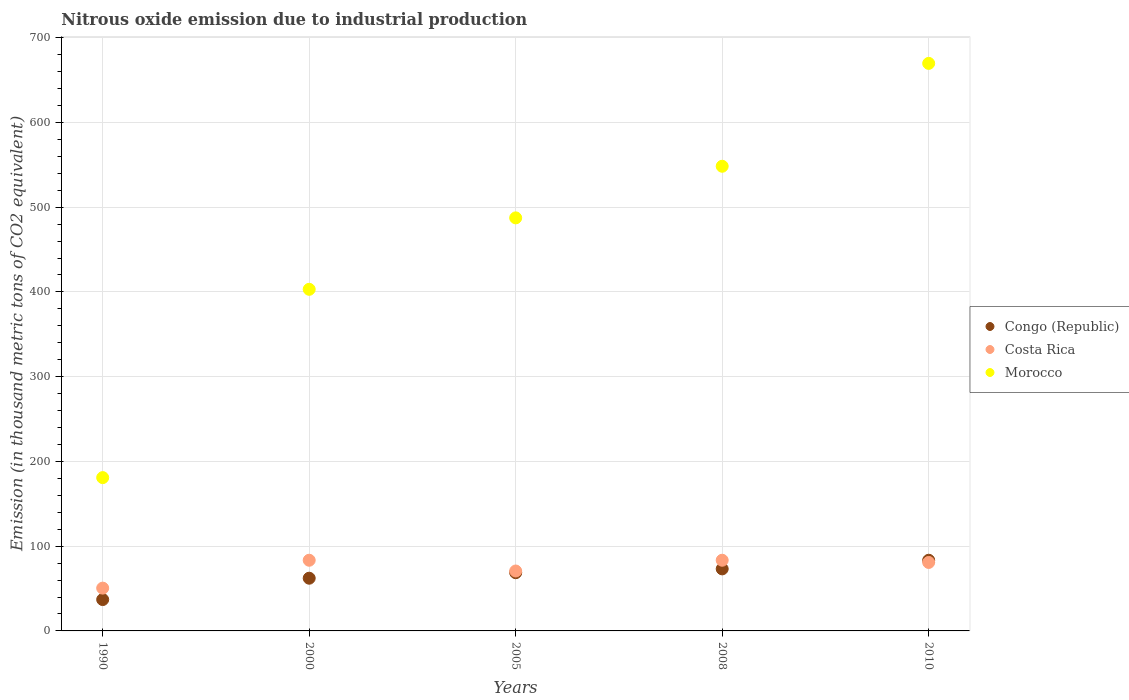What is the amount of nitrous oxide emitted in Congo (Republic) in 2005?
Ensure brevity in your answer.  68.7. Across all years, what is the maximum amount of nitrous oxide emitted in Costa Rica?
Ensure brevity in your answer.  83.4. Across all years, what is the minimum amount of nitrous oxide emitted in Morocco?
Your answer should be compact. 180.9. In which year was the amount of nitrous oxide emitted in Morocco minimum?
Your answer should be very brief. 1990. What is the total amount of nitrous oxide emitted in Congo (Republic) in the graph?
Provide a succinct answer. 324.5. What is the difference between the amount of nitrous oxide emitted in Costa Rica in 2000 and that in 2005?
Offer a terse response. 12.7. What is the difference between the amount of nitrous oxide emitted in Costa Rica in 2005 and the amount of nitrous oxide emitted in Congo (Republic) in 2010?
Your answer should be compact. -12.7. What is the average amount of nitrous oxide emitted in Morocco per year?
Offer a terse response. 457.88. In the year 2005, what is the difference between the amount of nitrous oxide emitted in Morocco and amount of nitrous oxide emitted in Costa Rica?
Your answer should be compact. 416.7. What is the ratio of the amount of nitrous oxide emitted in Congo (Republic) in 1990 to that in 2010?
Provide a succinct answer. 0.44. Is the amount of nitrous oxide emitted in Congo (Republic) in 1990 less than that in 2000?
Make the answer very short. Yes. What is the difference between the highest and the second highest amount of nitrous oxide emitted in Morocco?
Provide a short and direct response. 121.4. What is the difference between the highest and the lowest amount of nitrous oxide emitted in Costa Rica?
Provide a succinct answer. 32.9. In how many years, is the amount of nitrous oxide emitted in Costa Rica greater than the average amount of nitrous oxide emitted in Costa Rica taken over all years?
Keep it short and to the point. 3. Is the sum of the amount of nitrous oxide emitted in Congo (Republic) in 1990 and 2000 greater than the maximum amount of nitrous oxide emitted in Costa Rica across all years?
Offer a very short reply. Yes. How many dotlines are there?
Offer a terse response. 3. What is the difference between two consecutive major ticks on the Y-axis?
Keep it short and to the point. 100. Are the values on the major ticks of Y-axis written in scientific E-notation?
Keep it short and to the point. No. How many legend labels are there?
Ensure brevity in your answer.  3. How are the legend labels stacked?
Ensure brevity in your answer.  Vertical. What is the title of the graph?
Give a very brief answer. Nitrous oxide emission due to industrial production. Does "Belgium" appear as one of the legend labels in the graph?
Offer a terse response. No. What is the label or title of the Y-axis?
Give a very brief answer. Emission (in thousand metric tons of CO2 equivalent). What is the Emission (in thousand metric tons of CO2 equivalent) of Congo (Republic) in 1990?
Make the answer very short. 37. What is the Emission (in thousand metric tons of CO2 equivalent) of Costa Rica in 1990?
Your answer should be compact. 50.5. What is the Emission (in thousand metric tons of CO2 equivalent) of Morocco in 1990?
Provide a short and direct response. 180.9. What is the Emission (in thousand metric tons of CO2 equivalent) in Congo (Republic) in 2000?
Provide a succinct answer. 62.2. What is the Emission (in thousand metric tons of CO2 equivalent) of Costa Rica in 2000?
Give a very brief answer. 83.4. What is the Emission (in thousand metric tons of CO2 equivalent) in Morocco in 2000?
Provide a succinct answer. 403.1. What is the Emission (in thousand metric tons of CO2 equivalent) of Congo (Republic) in 2005?
Make the answer very short. 68.7. What is the Emission (in thousand metric tons of CO2 equivalent) of Costa Rica in 2005?
Your response must be concise. 70.7. What is the Emission (in thousand metric tons of CO2 equivalent) in Morocco in 2005?
Offer a very short reply. 487.4. What is the Emission (in thousand metric tons of CO2 equivalent) in Congo (Republic) in 2008?
Your answer should be very brief. 73.2. What is the Emission (in thousand metric tons of CO2 equivalent) in Costa Rica in 2008?
Provide a succinct answer. 83.4. What is the Emission (in thousand metric tons of CO2 equivalent) in Morocco in 2008?
Your answer should be compact. 548.3. What is the Emission (in thousand metric tons of CO2 equivalent) of Congo (Republic) in 2010?
Keep it short and to the point. 83.4. What is the Emission (in thousand metric tons of CO2 equivalent) in Costa Rica in 2010?
Offer a very short reply. 80.8. What is the Emission (in thousand metric tons of CO2 equivalent) of Morocco in 2010?
Offer a terse response. 669.7. Across all years, what is the maximum Emission (in thousand metric tons of CO2 equivalent) in Congo (Republic)?
Offer a very short reply. 83.4. Across all years, what is the maximum Emission (in thousand metric tons of CO2 equivalent) of Costa Rica?
Offer a very short reply. 83.4. Across all years, what is the maximum Emission (in thousand metric tons of CO2 equivalent) in Morocco?
Make the answer very short. 669.7. Across all years, what is the minimum Emission (in thousand metric tons of CO2 equivalent) of Congo (Republic)?
Your response must be concise. 37. Across all years, what is the minimum Emission (in thousand metric tons of CO2 equivalent) in Costa Rica?
Ensure brevity in your answer.  50.5. Across all years, what is the minimum Emission (in thousand metric tons of CO2 equivalent) in Morocco?
Your response must be concise. 180.9. What is the total Emission (in thousand metric tons of CO2 equivalent) in Congo (Republic) in the graph?
Your response must be concise. 324.5. What is the total Emission (in thousand metric tons of CO2 equivalent) in Costa Rica in the graph?
Give a very brief answer. 368.8. What is the total Emission (in thousand metric tons of CO2 equivalent) in Morocco in the graph?
Give a very brief answer. 2289.4. What is the difference between the Emission (in thousand metric tons of CO2 equivalent) of Congo (Republic) in 1990 and that in 2000?
Your answer should be very brief. -25.2. What is the difference between the Emission (in thousand metric tons of CO2 equivalent) in Costa Rica in 1990 and that in 2000?
Make the answer very short. -32.9. What is the difference between the Emission (in thousand metric tons of CO2 equivalent) in Morocco in 1990 and that in 2000?
Your answer should be compact. -222.2. What is the difference between the Emission (in thousand metric tons of CO2 equivalent) of Congo (Republic) in 1990 and that in 2005?
Offer a very short reply. -31.7. What is the difference between the Emission (in thousand metric tons of CO2 equivalent) of Costa Rica in 1990 and that in 2005?
Keep it short and to the point. -20.2. What is the difference between the Emission (in thousand metric tons of CO2 equivalent) in Morocco in 1990 and that in 2005?
Provide a succinct answer. -306.5. What is the difference between the Emission (in thousand metric tons of CO2 equivalent) of Congo (Republic) in 1990 and that in 2008?
Provide a short and direct response. -36.2. What is the difference between the Emission (in thousand metric tons of CO2 equivalent) of Costa Rica in 1990 and that in 2008?
Your answer should be compact. -32.9. What is the difference between the Emission (in thousand metric tons of CO2 equivalent) of Morocco in 1990 and that in 2008?
Provide a short and direct response. -367.4. What is the difference between the Emission (in thousand metric tons of CO2 equivalent) in Congo (Republic) in 1990 and that in 2010?
Keep it short and to the point. -46.4. What is the difference between the Emission (in thousand metric tons of CO2 equivalent) in Costa Rica in 1990 and that in 2010?
Offer a terse response. -30.3. What is the difference between the Emission (in thousand metric tons of CO2 equivalent) of Morocco in 1990 and that in 2010?
Your answer should be compact. -488.8. What is the difference between the Emission (in thousand metric tons of CO2 equivalent) of Costa Rica in 2000 and that in 2005?
Provide a succinct answer. 12.7. What is the difference between the Emission (in thousand metric tons of CO2 equivalent) of Morocco in 2000 and that in 2005?
Give a very brief answer. -84.3. What is the difference between the Emission (in thousand metric tons of CO2 equivalent) in Congo (Republic) in 2000 and that in 2008?
Offer a very short reply. -11. What is the difference between the Emission (in thousand metric tons of CO2 equivalent) in Morocco in 2000 and that in 2008?
Give a very brief answer. -145.2. What is the difference between the Emission (in thousand metric tons of CO2 equivalent) of Congo (Republic) in 2000 and that in 2010?
Ensure brevity in your answer.  -21.2. What is the difference between the Emission (in thousand metric tons of CO2 equivalent) of Costa Rica in 2000 and that in 2010?
Ensure brevity in your answer.  2.6. What is the difference between the Emission (in thousand metric tons of CO2 equivalent) of Morocco in 2000 and that in 2010?
Offer a very short reply. -266.6. What is the difference between the Emission (in thousand metric tons of CO2 equivalent) of Congo (Republic) in 2005 and that in 2008?
Provide a succinct answer. -4.5. What is the difference between the Emission (in thousand metric tons of CO2 equivalent) in Costa Rica in 2005 and that in 2008?
Make the answer very short. -12.7. What is the difference between the Emission (in thousand metric tons of CO2 equivalent) in Morocco in 2005 and that in 2008?
Offer a very short reply. -60.9. What is the difference between the Emission (in thousand metric tons of CO2 equivalent) in Congo (Republic) in 2005 and that in 2010?
Provide a succinct answer. -14.7. What is the difference between the Emission (in thousand metric tons of CO2 equivalent) in Costa Rica in 2005 and that in 2010?
Keep it short and to the point. -10.1. What is the difference between the Emission (in thousand metric tons of CO2 equivalent) in Morocco in 2005 and that in 2010?
Your answer should be compact. -182.3. What is the difference between the Emission (in thousand metric tons of CO2 equivalent) of Congo (Republic) in 2008 and that in 2010?
Provide a short and direct response. -10.2. What is the difference between the Emission (in thousand metric tons of CO2 equivalent) in Costa Rica in 2008 and that in 2010?
Your answer should be compact. 2.6. What is the difference between the Emission (in thousand metric tons of CO2 equivalent) in Morocco in 2008 and that in 2010?
Give a very brief answer. -121.4. What is the difference between the Emission (in thousand metric tons of CO2 equivalent) of Congo (Republic) in 1990 and the Emission (in thousand metric tons of CO2 equivalent) of Costa Rica in 2000?
Provide a succinct answer. -46.4. What is the difference between the Emission (in thousand metric tons of CO2 equivalent) in Congo (Republic) in 1990 and the Emission (in thousand metric tons of CO2 equivalent) in Morocco in 2000?
Give a very brief answer. -366.1. What is the difference between the Emission (in thousand metric tons of CO2 equivalent) in Costa Rica in 1990 and the Emission (in thousand metric tons of CO2 equivalent) in Morocco in 2000?
Make the answer very short. -352.6. What is the difference between the Emission (in thousand metric tons of CO2 equivalent) in Congo (Republic) in 1990 and the Emission (in thousand metric tons of CO2 equivalent) in Costa Rica in 2005?
Your answer should be very brief. -33.7. What is the difference between the Emission (in thousand metric tons of CO2 equivalent) in Congo (Republic) in 1990 and the Emission (in thousand metric tons of CO2 equivalent) in Morocco in 2005?
Give a very brief answer. -450.4. What is the difference between the Emission (in thousand metric tons of CO2 equivalent) in Costa Rica in 1990 and the Emission (in thousand metric tons of CO2 equivalent) in Morocco in 2005?
Your answer should be compact. -436.9. What is the difference between the Emission (in thousand metric tons of CO2 equivalent) of Congo (Republic) in 1990 and the Emission (in thousand metric tons of CO2 equivalent) of Costa Rica in 2008?
Your response must be concise. -46.4. What is the difference between the Emission (in thousand metric tons of CO2 equivalent) in Congo (Republic) in 1990 and the Emission (in thousand metric tons of CO2 equivalent) in Morocco in 2008?
Offer a terse response. -511.3. What is the difference between the Emission (in thousand metric tons of CO2 equivalent) of Costa Rica in 1990 and the Emission (in thousand metric tons of CO2 equivalent) of Morocco in 2008?
Offer a very short reply. -497.8. What is the difference between the Emission (in thousand metric tons of CO2 equivalent) of Congo (Republic) in 1990 and the Emission (in thousand metric tons of CO2 equivalent) of Costa Rica in 2010?
Keep it short and to the point. -43.8. What is the difference between the Emission (in thousand metric tons of CO2 equivalent) of Congo (Republic) in 1990 and the Emission (in thousand metric tons of CO2 equivalent) of Morocco in 2010?
Offer a very short reply. -632.7. What is the difference between the Emission (in thousand metric tons of CO2 equivalent) of Costa Rica in 1990 and the Emission (in thousand metric tons of CO2 equivalent) of Morocco in 2010?
Give a very brief answer. -619.2. What is the difference between the Emission (in thousand metric tons of CO2 equivalent) of Congo (Republic) in 2000 and the Emission (in thousand metric tons of CO2 equivalent) of Morocco in 2005?
Your answer should be very brief. -425.2. What is the difference between the Emission (in thousand metric tons of CO2 equivalent) in Costa Rica in 2000 and the Emission (in thousand metric tons of CO2 equivalent) in Morocco in 2005?
Keep it short and to the point. -404. What is the difference between the Emission (in thousand metric tons of CO2 equivalent) of Congo (Republic) in 2000 and the Emission (in thousand metric tons of CO2 equivalent) of Costa Rica in 2008?
Give a very brief answer. -21.2. What is the difference between the Emission (in thousand metric tons of CO2 equivalent) of Congo (Republic) in 2000 and the Emission (in thousand metric tons of CO2 equivalent) of Morocco in 2008?
Your answer should be very brief. -486.1. What is the difference between the Emission (in thousand metric tons of CO2 equivalent) of Costa Rica in 2000 and the Emission (in thousand metric tons of CO2 equivalent) of Morocco in 2008?
Keep it short and to the point. -464.9. What is the difference between the Emission (in thousand metric tons of CO2 equivalent) of Congo (Republic) in 2000 and the Emission (in thousand metric tons of CO2 equivalent) of Costa Rica in 2010?
Ensure brevity in your answer.  -18.6. What is the difference between the Emission (in thousand metric tons of CO2 equivalent) in Congo (Republic) in 2000 and the Emission (in thousand metric tons of CO2 equivalent) in Morocco in 2010?
Provide a short and direct response. -607.5. What is the difference between the Emission (in thousand metric tons of CO2 equivalent) in Costa Rica in 2000 and the Emission (in thousand metric tons of CO2 equivalent) in Morocco in 2010?
Offer a very short reply. -586.3. What is the difference between the Emission (in thousand metric tons of CO2 equivalent) in Congo (Republic) in 2005 and the Emission (in thousand metric tons of CO2 equivalent) in Costa Rica in 2008?
Offer a very short reply. -14.7. What is the difference between the Emission (in thousand metric tons of CO2 equivalent) in Congo (Republic) in 2005 and the Emission (in thousand metric tons of CO2 equivalent) in Morocco in 2008?
Your answer should be compact. -479.6. What is the difference between the Emission (in thousand metric tons of CO2 equivalent) of Costa Rica in 2005 and the Emission (in thousand metric tons of CO2 equivalent) of Morocco in 2008?
Offer a very short reply. -477.6. What is the difference between the Emission (in thousand metric tons of CO2 equivalent) in Congo (Republic) in 2005 and the Emission (in thousand metric tons of CO2 equivalent) in Costa Rica in 2010?
Your answer should be compact. -12.1. What is the difference between the Emission (in thousand metric tons of CO2 equivalent) in Congo (Republic) in 2005 and the Emission (in thousand metric tons of CO2 equivalent) in Morocco in 2010?
Provide a succinct answer. -601. What is the difference between the Emission (in thousand metric tons of CO2 equivalent) of Costa Rica in 2005 and the Emission (in thousand metric tons of CO2 equivalent) of Morocco in 2010?
Give a very brief answer. -599. What is the difference between the Emission (in thousand metric tons of CO2 equivalent) in Congo (Republic) in 2008 and the Emission (in thousand metric tons of CO2 equivalent) in Morocco in 2010?
Offer a terse response. -596.5. What is the difference between the Emission (in thousand metric tons of CO2 equivalent) of Costa Rica in 2008 and the Emission (in thousand metric tons of CO2 equivalent) of Morocco in 2010?
Ensure brevity in your answer.  -586.3. What is the average Emission (in thousand metric tons of CO2 equivalent) in Congo (Republic) per year?
Provide a short and direct response. 64.9. What is the average Emission (in thousand metric tons of CO2 equivalent) of Costa Rica per year?
Provide a succinct answer. 73.76. What is the average Emission (in thousand metric tons of CO2 equivalent) of Morocco per year?
Your answer should be compact. 457.88. In the year 1990, what is the difference between the Emission (in thousand metric tons of CO2 equivalent) in Congo (Republic) and Emission (in thousand metric tons of CO2 equivalent) in Costa Rica?
Ensure brevity in your answer.  -13.5. In the year 1990, what is the difference between the Emission (in thousand metric tons of CO2 equivalent) of Congo (Republic) and Emission (in thousand metric tons of CO2 equivalent) of Morocco?
Keep it short and to the point. -143.9. In the year 1990, what is the difference between the Emission (in thousand metric tons of CO2 equivalent) of Costa Rica and Emission (in thousand metric tons of CO2 equivalent) of Morocco?
Give a very brief answer. -130.4. In the year 2000, what is the difference between the Emission (in thousand metric tons of CO2 equivalent) of Congo (Republic) and Emission (in thousand metric tons of CO2 equivalent) of Costa Rica?
Your answer should be compact. -21.2. In the year 2000, what is the difference between the Emission (in thousand metric tons of CO2 equivalent) of Congo (Republic) and Emission (in thousand metric tons of CO2 equivalent) of Morocco?
Keep it short and to the point. -340.9. In the year 2000, what is the difference between the Emission (in thousand metric tons of CO2 equivalent) in Costa Rica and Emission (in thousand metric tons of CO2 equivalent) in Morocco?
Provide a succinct answer. -319.7. In the year 2005, what is the difference between the Emission (in thousand metric tons of CO2 equivalent) of Congo (Republic) and Emission (in thousand metric tons of CO2 equivalent) of Morocco?
Offer a very short reply. -418.7. In the year 2005, what is the difference between the Emission (in thousand metric tons of CO2 equivalent) in Costa Rica and Emission (in thousand metric tons of CO2 equivalent) in Morocco?
Keep it short and to the point. -416.7. In the year 2008, what is the difference between the Emission (in thousand metric tons of CO2 equivalent) in Congo (Republic) and Emission (in thousand metric tons of CO2 equivalent) in Costa Rica?
Provide a succinct answer. -10.2. In the year 2008, what is the difference between the Emission (in thousand metric tons of CO2 equivalent) of Congo (Republic) and Emission (in thousand metric tons of CO2 equivalent) of Morocco?
Your answer should be very brief. -475.1. In the year 2008, what is the difference between the Emission (in thousand metric tons of CO2 equivalent) of Costa Rica and Emission (in thousand metric tons of CO2 equivalent) of Morocco?
Provide a succinct answer. -464.9. In the year 2010, what is the difference between the Emission (in thousand metric tons of CO2 equivalent) of Congo (Republic) and Emission (in thousand metric tons of CO2 equivalent) of Costa Rica?
Ensure brevity in your answer.  2.6. In the year 2010, what is the difference between the Emission (in thousand metric tons of CO2 equivalent) of Congo (Republic) and Emission (in thousand metric tons of CO2 equivalent) of Morocco?
Your answer should be compact. -586.3. In the year 2010, what is the difference between the Emission (in thousand metric tons of CO2 equivalent) of Costa Rica and Emission (in thousand metric tons of CO2 equivalent) of Morocco?
Your response must be concise. -588.9. What is the ratio of the Emission (in thousand metric tons of CO2 equivalent) of Congo (Republic) in 1990 to that in 2000?
Provide a succinct answer. 0.59. What is the ratio of the Emission (in thousand metric tons of CO2 equivalent) in Costa Rica in 1990 to that in 2000?
Your answer should be compact. 0.61. What is the ratio of the Emission (in thousand metric tons of CO2 equivalent) in Morocco in 1990 to that in 2000?
Your answer should be very brief. 0.45. What is the ratio of the Emission (in thousand metric tons of CO2 equivalent) in Congo (Republic) in 1990 to that in 2005?
Offer a terse response. 0.54. What is the ratio of the Emission (in thousand metric tons of CO2 equivalent) of Costa Rica in 1990 to that in 2005?
Give a very brief answer. 0.71. What is the ratio of the Emission (in thousand metric tons of CO2 equivalent) in Morocco in 1990 to that in 2005?
Keep it short and to the point. 0.37. What is the ratio of the Emission (in thousand metric tons of CO2 equivalent) in Congo (Republic) in 1990 to that in 2008?
Offer a very short reply. 0.51. What is the ratio of the Emission (in thousand metric tons of CO2 equivalent) of Costa Rica in 1990 to that in 2008?
Give a very brief answer. 0.61. What is the ratio of the Emission (in thousand metric tons of CO2 equivalent) in Morocco in 1990 to that in 2008?
Ensure brevity in your answer.  0.33. What is the ratio of the Emission (in thousand metric tons of CO2 equivalent) in Congo (Republic) in 1990 to that in 2010?
Your answer should be compact. 0.44. What is the ratio of the Emission (in thousand metric tons of CO2 equivalent) of Morocco in 1990 to that in 2010?
Your answer should be very brief. 0.27. What is the ratio of the Emission (in thousand metric tons of CO2 equivalent) of Congo (Republic) in 2000 to that in 2005?
Your answer should be compact. 0.91. What is the ratio of the Emission (in thousand metric tons of CO2 equivalent) in Costa Rica in 2000 to that in 2005?
Provide a short and direct response. 1.18. What is the ratio of the Emission (in thousand metric tons of CO2 equivalent) of Morocco in 2000 to that in 2005?
Give a very brief answer. 0.83. What is the ratio of the Emission (in thousand metric tons of CO2 equivalent) in Congo (Republic) in 2000 to that in 2008?
Offer a very short reply. 0.85. What is the ratio of the Emission (in thousand metric tons of CO2 equivalent) in Morocco in 2000 to that in 2008?
Provide a succinct answer. 0.74. What is the ratio of the Emission (in thousand metric tons of CO2 equivalent) of Congo (Republic) in 2000 to that in 2010?
Provide a succinct answer. 0.75. What is the ratio of the Emission (in thousand metric tons of CO2 equivalent) of Costa Rica in 2000 to that in 2010?
Provide a short and direct response. 1.03. What is the ratio of the Emission (in thousand metric tons of CO2 equivalent) in Morocco in 2000 to that in 2010?
Give a very brief answer. 0.6. What is the ratio of the Emission (in thousand metric tons of CO2 equivalent) in Congo (Republic) in 2005 to that in 2008?
Offer a very short reply. 0.94. What is the ratio of the Emission (in thousand metric tons of CO2 equivalent) of Costa Rica in 2005 to that in 2008?
Provide a short and direct response. 0.85. What is the ratio of the Emission (in thousand metric tons of CO2 equivalent) in Morocco in 2005 to that in 2008?
Provide a succinct answer. 0.89. What is the ratio of the Emission (in thousand metric tons of CO2 equivalent) of Congo (Republic) in 2005 to that in 2010?
Make the answer very short. 0.82. What is the ratio of the Emission (in thousand metric tons of CO2 equivalent) of Costa Rica in 2005 to that in 2010?
Offer a terse response. 0.88. What is the ratio of the Emission (in thousand metric tons of CO2 equivalent) of Morocco in 2005 to that in 2010?
Provide a short and direct response. 0.73. What is the ratio of the Emission (in thousand metric tons of CO2 equivalent) of Congo (Republic) in 2008 to that in 2010?
Your response must be concise. 0.88. What is the ratio of the Emission (in thousand metric tons of CO2 equivalent) of Costa Rica in 2008 to that in 2010?
Provide a succinct answer. 1.03. What is the ratio of the Emission (in thousand metric tons of CO2 equivalent) of Morocco in 2008 to that in 2010?
Your answer should be compact. 0.82. What is the difference between the highest and the second highest Emission (in thousand metric tons of CO2 equivalent) in Morocco?
Your answer should be compact. 121.4. What is the difference between the highest and the lowest Emission (in thousand metric tons of CO2 equivalent) of Congo (Republic)?
Make the answer very short. 46.4. What is the difference between the highest and the lowest Emission (in thousand metric tons of CO2 equivalent) in Costa Rica?
Your answer should be very brief. 32.9. What is the difference between the highest and the lowest Emission (in thousand metric tons of CO2 equivalent) in Morocco?
Offer a terse response. 488.8. 